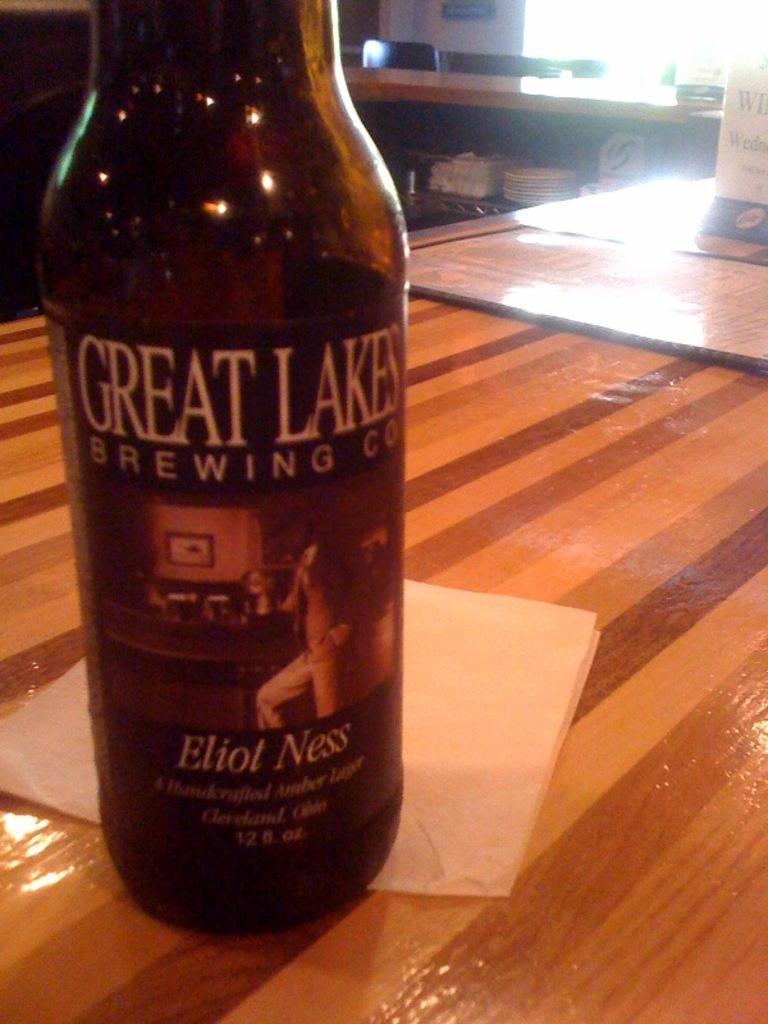<image>
Write a terse but informative summary of the picture. A bottle of Eliot Ness, made by Great Lakes brewing company os half on a paper towel, on a wooden table. 